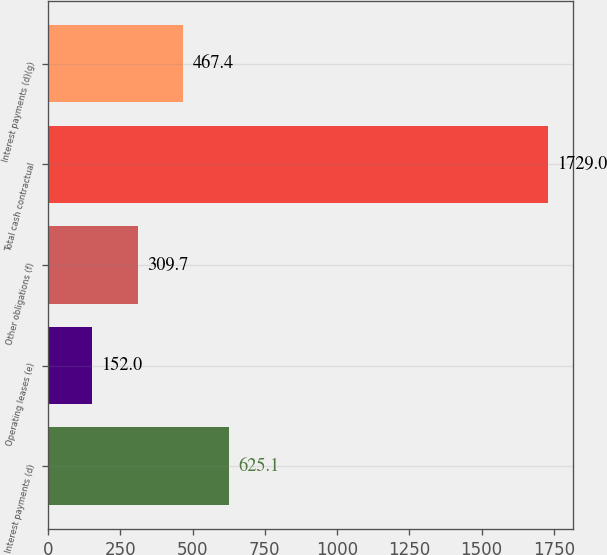<chart> <loc_0><loc_0><loc_500><loc_500><bar_chart><fcel>Interest payments (d)<fcel>Operating leases (e)<fcel>Other obligations (f)<fcel>Total cash contractual<fcel>Interest payments (d)(g)<nl><fcel>625.1<fcel>152<fcel>309.7<fcel>1729<fcel>467.4<nl></chart> 